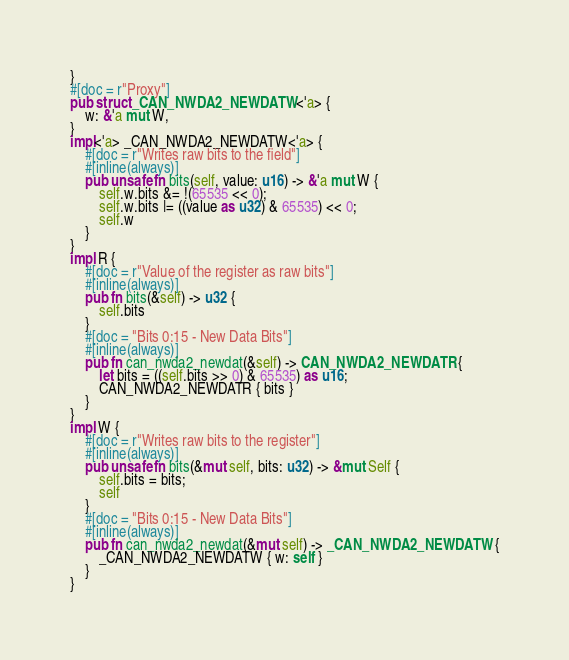<code> <loc_0><loc_0><loc_500><loc_500><_Rust_>}
#[doc = r"Proxy"]
pub struct _CAN_NWDA2_NEWDATW<'a> {
    w: &'a mut W,
}
impl<'a> _CAN_NWDA2_NEWDATW<'a> {
    #[doc = r"Writes raw bits to the field"]
    #[inline(always)]
    pub unsafe fn bits(self, value: u16) -> &'a mut W {
        self.w.bits &= !(65535 << 0);
        self.w.bits |= ((value as u32) & 65535) << 0;
        self.w
    }
}
impl R {
    #[doc = r"Value of the register as raw bits"]
    #[inline(always)]
    pub fn bits(&self) -> u32 {
        self.bits
    }
    #[doc = "Bits 0:15 - New Data Bits"]
    #[inline(always)]
    pub fn can_nwda2_newdat(&self) -> CAN_NWDA2_NEWDATR {
        let bits = ((self.bits >> 0) & 65535) as u16;
        CAN_NWDA2_NEWDATR { bits }
    }
}
impl W {
    #[doc = r"Writes raw bits to the register"]
    #[inline(always)]
    pub unsafe fn bits(&mut self, bits: u32) -> &mut Self {
        self.bits = bits;
        self
    }
    #[doc = "Bits 0:15 - New Data Bits"]
    #[inline(always)]
    pub fn can_nwda2_newdat(&mut self) -> _CAN_NWDA2_NEWDATW {
        _CAN_NWDA2_NEWDATW { w: self }
    }
}
</code> 